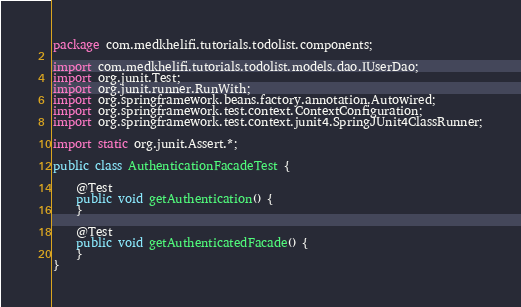Convert code to text. <code><loc_0><loc_0><loc_500><loc_500><_Java_>package com.medkhelifi.tutorials.todolist.components;

import com.medkhelifi.tutorials.todolist.models.dao.IUserDao;
import org.junit.Test;
import org.junit.runner.RunWith;
import org.springframework.beans.factory.annotation.Autowired;
import org.springframework.test.context.ContextConfiguration;
import org.springframework.test.context.junit4.SpringJUnit4ClassRunner;

import static org.junit.Assert.*;

public class AuthenticationFacadeTest {

    @Test
    public void getAuthentication() {
    }

    @Test
    public void getAuthenticatedFacade() {
    }
}</code> 